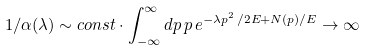Convert formula to latex. <formula><loc_0><loc_0><loc_500><loc_500>1 / \alpha ( \lambda ) \sim c o n s t \cdot \int _ { - \infty } ^ { \infty } d p \, p \, e ^ { - \lambda p ^ { 2 } \, / 2 E + N ( p ) / E } \to \infty</formula> 